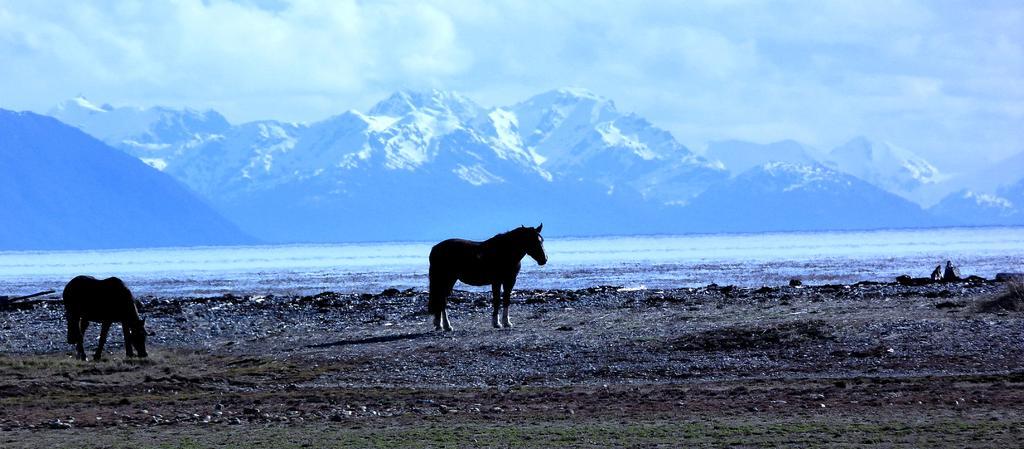Please provide a concise description of this image. In this picture, we can see two horses on the ground and we can see some objects, grass on the ground and we can see the river, hills and the sky with clouds. 